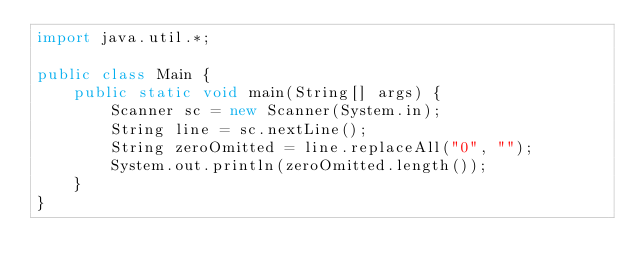<code> <loc_0><loc_0><loc_500><loc_500><_Java_>import java.util.*;

public class Main {
	public static void main(String[] args) {
    	Scanner sc = new Scanner(System.in);
      	String line = sc.nextLine();
      	String zeroOmitted = line.replaceAll("0", "");
        System.out.println(zeroOmitted.length());
    }
}</code> 